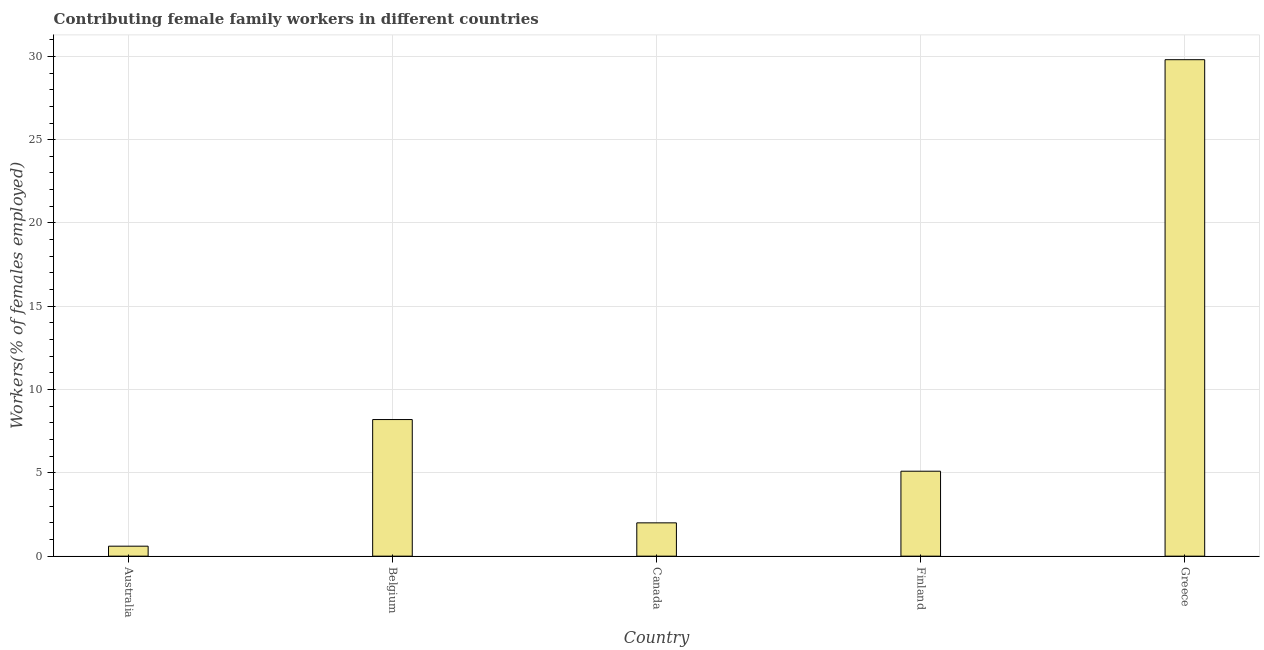Does the graph contain any zero values?
Give a very brief answer. No. Does the graph contain grids?
Provide a succinct answer. Yes. What is the title of the graph?
Offer a terse response. Contributing female family workers in different countries. What is the label or title of the X-axis?
Your answer should be compact. Country. What is the label or title of the Y-axis?
Your answer should be compact. Workers(% of females employed). What is the contributing female family workers in Canada?
Your response must be concise. 2. Across all countries, what is the maximum contributing female family workers?
Keep it short and to the point. 29.8. Across all countries, what is the minimum contributing female family workers?
Your answer should be very brief. 0.6. In which country was the contributing female family workers minimum?
Give a very brief answer. Australia. What is the sum of the contributing female family workers?
Keep it short and to the point. 45.7. What is the difference between the contributing female family workers in Belgium and Finland?
Your answer should be very brief. 3.1. What is the average contributing female family workers per country?
Keep it short and to the point. 9.14. What is the median contributing female family workers?
Your response must be concise. 5.1. What is the ratio of the contributing female family workers in Belgium to that in Canada?
Give a very brief answer. 4.1. Is the difference between the contributing female family workers in Australia and Belgium greater than the difference between any two countries?
Your response must be concise. No. What is the difference between the highest and the second highest contributing female family workers?
Provide a short and direct response. 21.6. What is the difference between the highest and the lowest contributing female family workers?
Keep it short and to the point. 29.2. In how many countries, is the contributing female family workers greater than the average contributing female family workers taken over all countries?
Give a very brief answer. 1. How many bars are there?
Your answer should be very brief. 5. Are the values on the major ticks of Y-axis written in scientific E-notation?
Offer a very short reply. No. What is the Workers(% of females employed) in Australia?
Give a very brief answer. 0.6. What is the Workers(% of females employed) of Belgium?
Give a very brief answer. 8.2. What is the Workers(% of females employed) in Canada?
Offer a terse response. 2. What is the Workers(% of females employed) of Finland?
Provide a succinct answer. 5.1. What is the Workers(% of females employed) of Greece?
Offer a very short reply. 29.8. What is the difference between the Workers(% of females employed) in Australia and Belgium?
Keep it short and to the point. -7.6. What is the difference between the Workers(% of females employed) in Australia and Canada?
Provide a short and direct response. -1.4. What is the difference between the Workers(% of females employed) in Australia and Finland?
Give a very brief answer. -4.5. What is the difference between the Workers(% of females employed) in Australia and Greece?
Your response must be concise. -29.2. What is the difference between the Workers(% of females employed) in Belgium and Finland?
Give a very brief answer. 3.1. What is the difference between the Workers(% of females employed) in Belgium and Greece?
Your answer should be very brief. -21.6. What is the difference between the Workers(% of females employed) in Canada and Finland?
Give a very brief answer. -3.1. What is the difference between the Workers(% of females employed) in Canada and Greece?
Give a very brief answer. -27.8. What is the difference between the Workers(% of females employed) in Finland and Greece?
Offer a terse response. -24.7. What is the ratio of the Workers(% of females employed) in Australia to that in Belgium?
Your answer should be very brief. 0.07. What is the ratio of the Workers(% of females employed) in Australia to that in Canada?
Keep it short and to the point. 0.3. What is the ratio of the Workers(% of females employed) in Australia to that in Finland?
Offer a very short reply. 0.12. What is the ratio of the Workers(% of females employed) in Belgium to that in Canada?
Provide a short and direct response. 4.1. What is the ratio of the Workers(% of females employed) in Belgium to that in Finland?
Provide a short and direct response. 1.61. What is the ratio of the Workers(% of females employed) in Belgium to that in Greece?
Make the answer very short. 0.28. What is the ratio of the Workers(% of females employed) in Canada to that in Finland?
Keep it short and to the point. 0.39. What is the ratio of the Workers(% of females employed) in Canada to that in Greece?
Provide a succinct answer. 0.07. What is the ratio of the Workers(% of females employed) in Finland to that in Greece?
Keep it short and to the point. 0.17. 